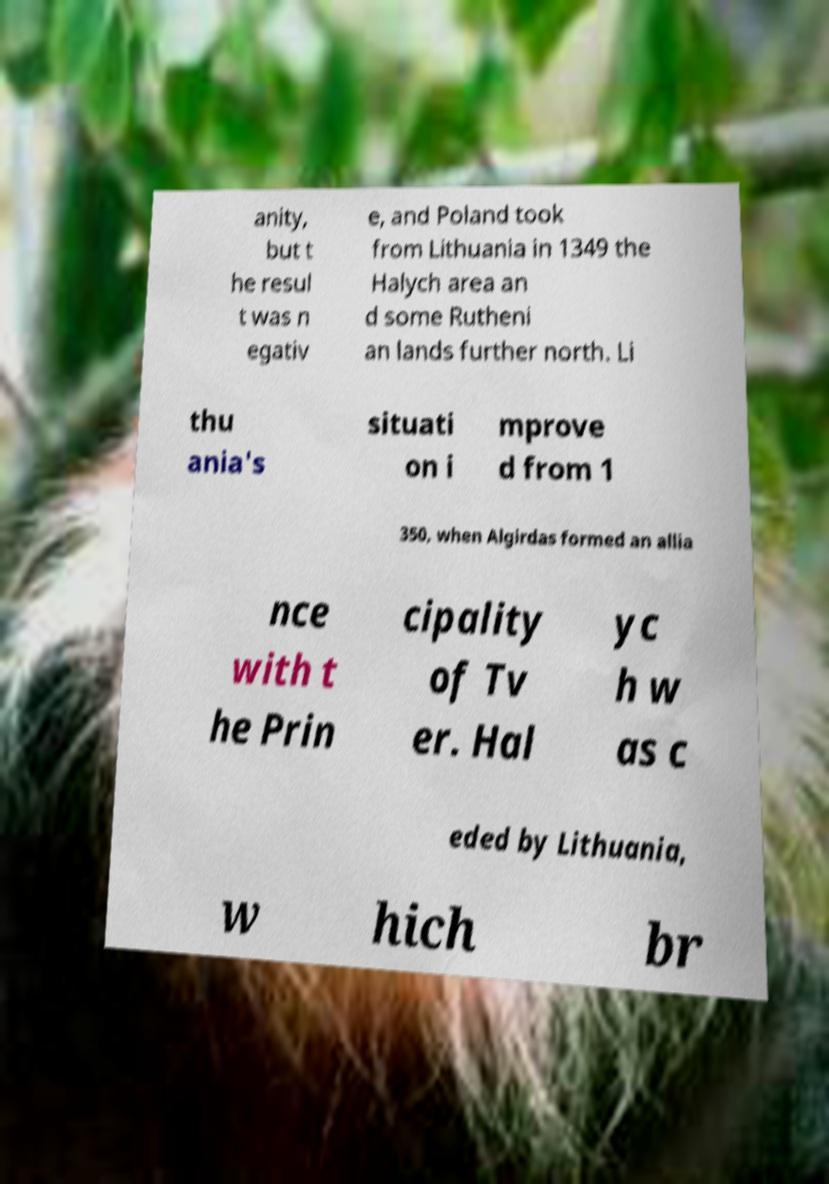I need the written content from this picture converted into text. Can you do that? anity, but t he resul t was n egativ e, and Poland took from Lithuania in 1349 the Halych area an d some Rutheni an lands further north. Li thu ania's situati on i mprove d from 1 350, when Algirdas formed an allia nce with t he Prin cipality of Tv er. Hal yc h w as c eded by Lithuania, w hich br 